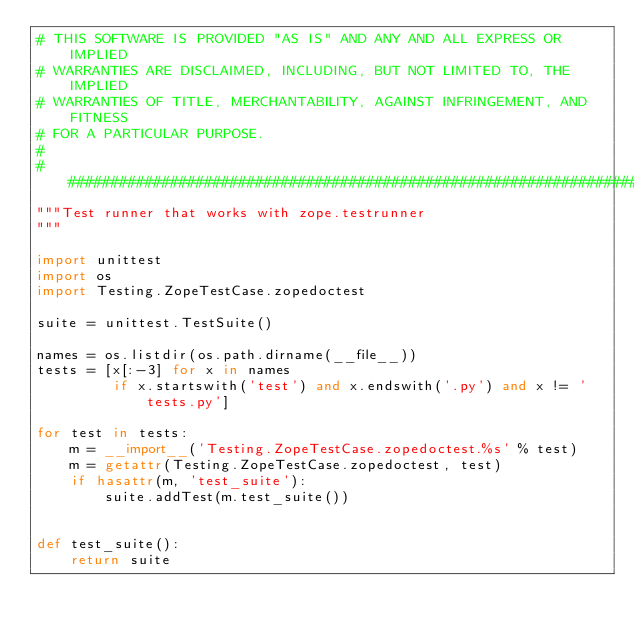Convert code to text. <code><loc_0><loc_0><loc_500><loc_500><_Python_># THIS SOFTWARE IS PROVIDED "AS IS" AND ANY AND ALL EXPRESS OR IMPLIED
# WARRANTIES ARE DISCLAIMED, INCLUDING, BUT NOT LIMITED TO, THE IMPLIED
# WARRANTIES OF TITLE, MERCHANTABILITY, AGAINST INFRINGEMENT, AND FITNESS
# FOR A PARTICULAR PURPOSE.
#
##############################################################################
"""Test runner that works with zope.testrunner
"""

import unittest
import os
import Testing.ZopeTestCase.zopedoctest

suite = unittest.TestSuite()

names = os.listdir(os.path.dirname(__file__))
tests = [x[:-3] for x in names
         if x.startswith('test') and x.endswith('.py') and x != 'tests.py']

for test in tests:
    m = __import__('Testing.ZopeTestCase.zopedoctest.%s' % test)
    m = getattr(Testing.ZopeTestCase.zopedoctest, test)
    if hasattr(m, 'test_suite'):
        suite.addTest(m.test_suite())


def test_suite():
    return suite
</code> 